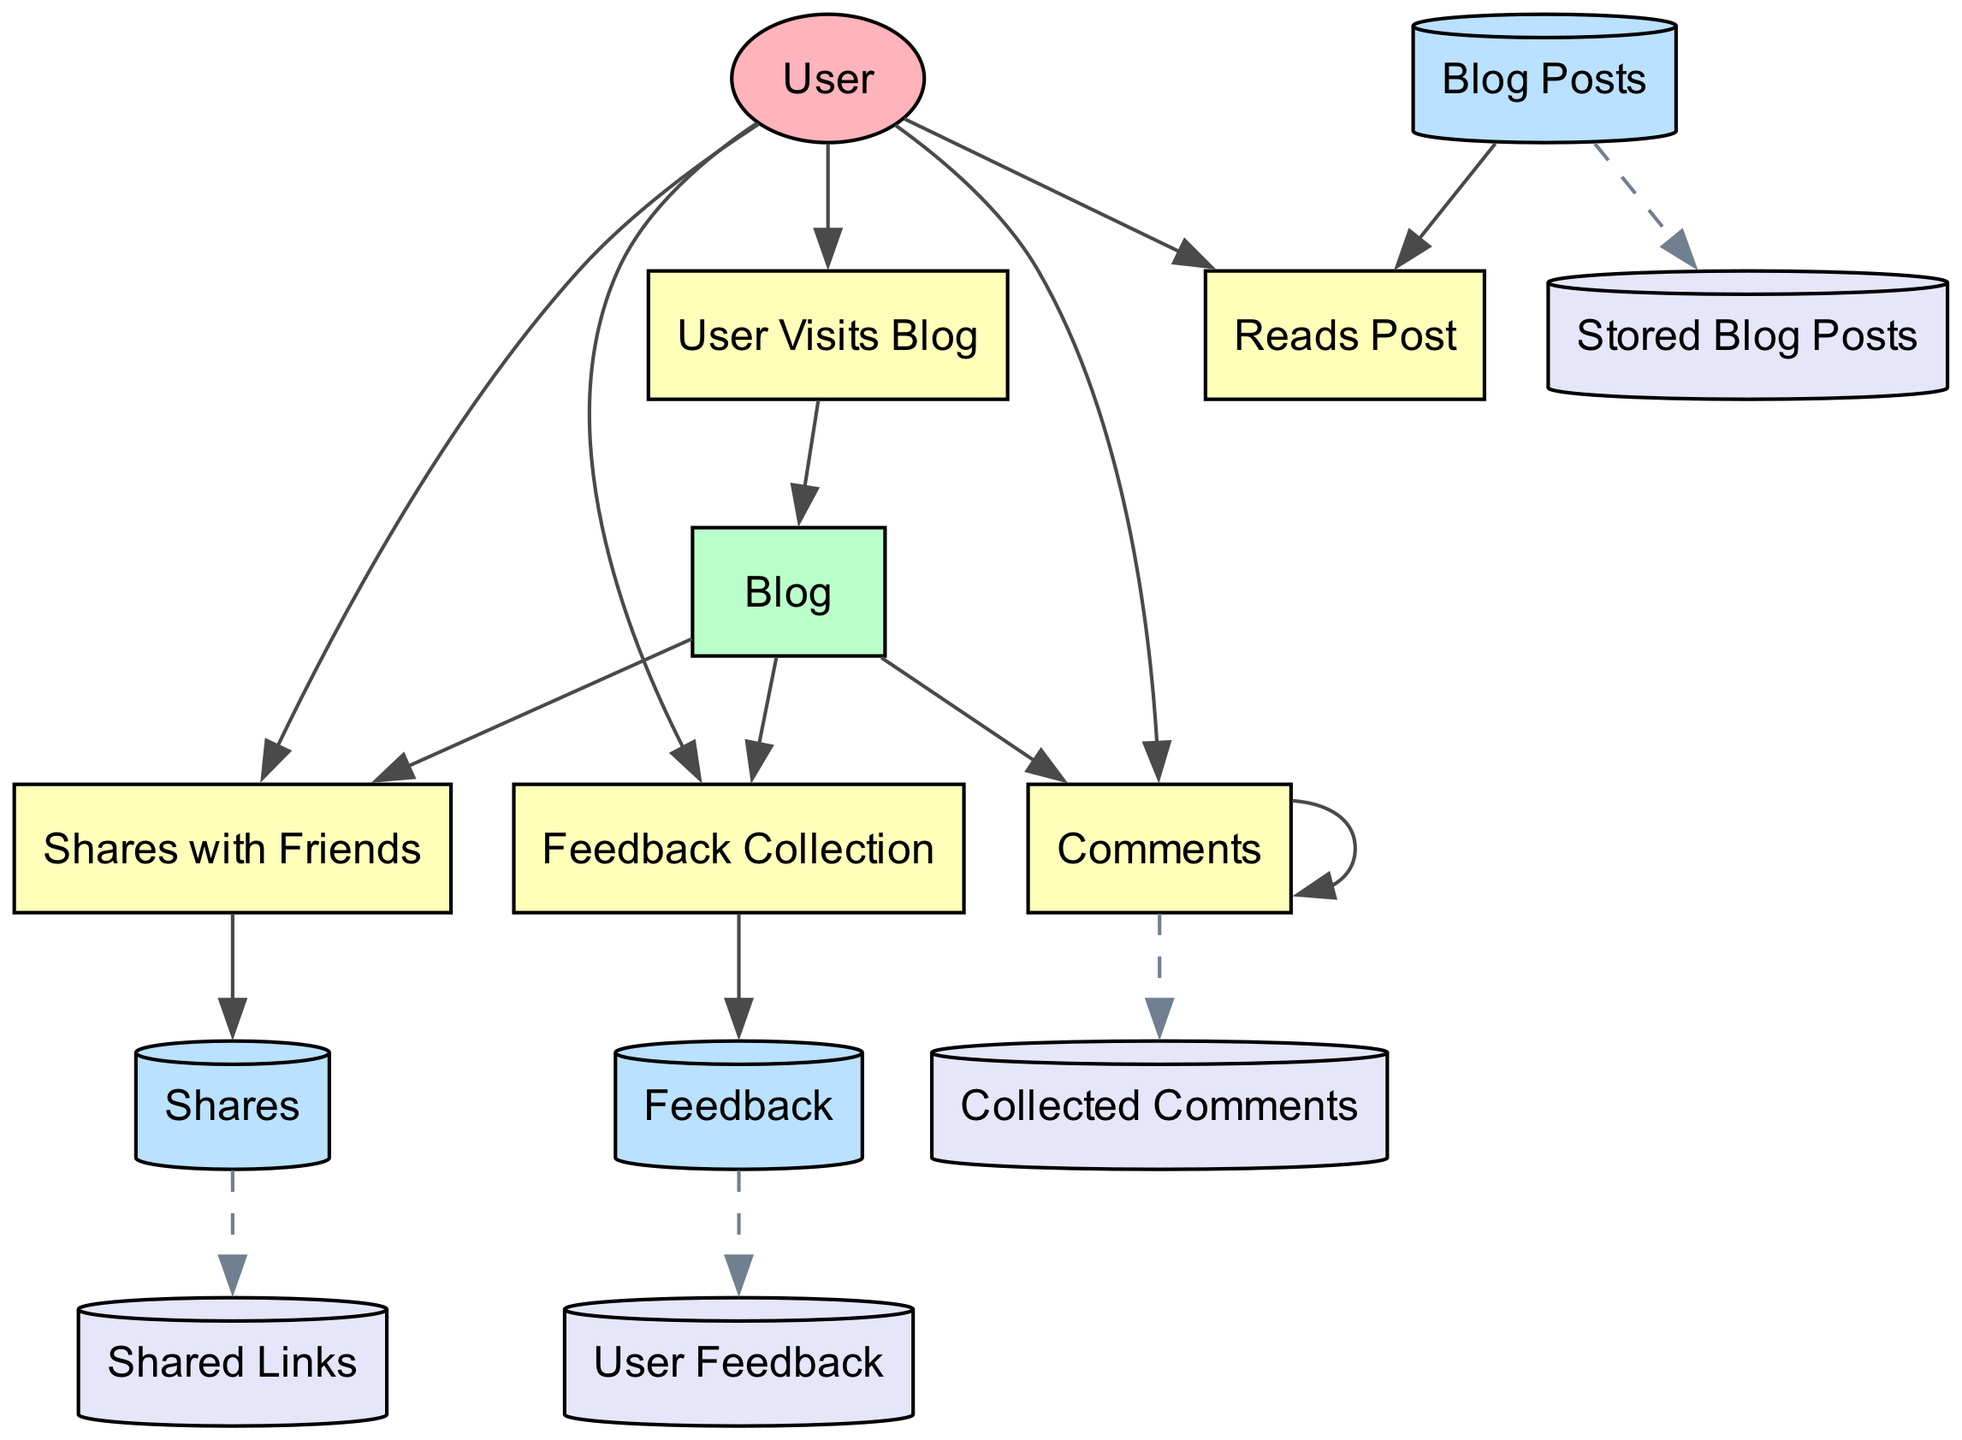What are the inputs for the process "User Visits Blog"? The inputs for the "User Visits Blog" process come from the "User" external entity, as it requires a user to initiate the visit.
Answer: User How many data stores are present in the diagram? The diagram includes four data stores which are "Stored Blog Posts," "Collected Comments," "Shared Links," and "User Feedback."
Answer: 4 What is the output of the "Comments" process? The output of the "Comments" process is directed to the "Comments" data store, where user comments are collected.
Answer: Comments Which process collects feedback from users? The "Feedback Collection" process is specifically designed to gather feedback from users visiting the blog.
Answer: Feedback Collection How many processes are there that the user can interact with after visiting the blog? After visiting the blog, the user can interact with three processes: "Reads Post," "Comments," and "Shares with Friends."
Answer: 3 Which data store is linked to the "Shares with Friends" process? The "Shares with Friends" process outputs information to the "Shares" data store, capturing the shared blog posts.
Answer: Shares What is the primary external entity in the diagram? The primary external entity in this diagram is the "User," who initiates all interactions with the blog.
Answer: User Which process has no outputs? The "Reads Post" process does not produce any output to a data store or another process; it simply involves user interaction with blog posts.
Answer: Reads Post What do the dashed edges in the diagram represent? The dashed edges in the diagram represent the flow of data towards the data stores, indicating that data like comments and shares are being stored.
Answer: Data storage flow 